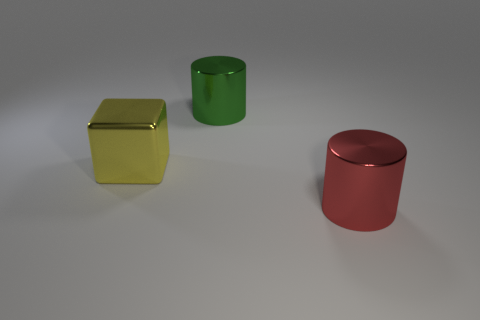Add 1 cyan shiny spheres. How many objects exist? 4 Subtract all cylinders. How many objects are left? 1 Add 1 yellow shiny objects. How many yellow shiny objects exist? 2 Subtract 0 purple cubes. How many objects are left? 3 Subtract all big cubes. Subtract all green objects. How many objects are left? 1 Add 2 red cylinders. How many red cylinders are left? 3 